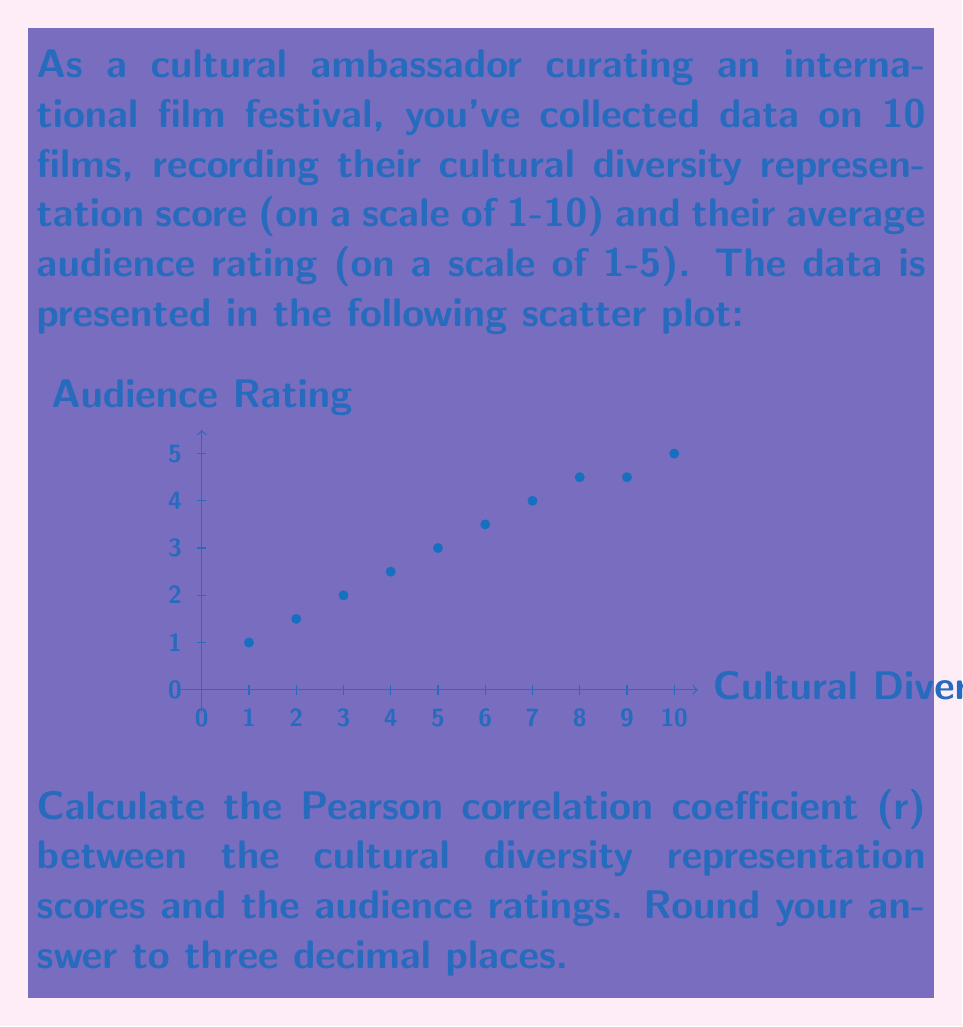Help me with this question. To calculate the Pearson correlation coefficient, we'll follow these steps:

1) First, let's organize our data:
   x (Cultural Diversity): 1, 2, 3, 4, 5, 6, 7, 8, 9, 10
   y (Audience Rating): 1, 1.5, 2, 2.5, 3, 3.5, 4, 4.5, 4.5, 5

2) Calculate the means:
   $\bar{x} = \frac{1+2+3+4+5+6+7+8+9+10}{10} = 5.5$
   $\bar{y} = \frac{1+1.5+2+2.5+3+3.5+4+4.5+4.5+5}{10} = 3.15$

3) Calculate the necessary sums:
   $\sum(x - \bar{x})(y - \bar{y})$
   $\sum(x - \bar{x})^2$
   $\sum(y - \bar{y})^2$

4) The formula for Pearson's r is:

   $$r = \frac{\sum(x - \bar{x})(y - \bar{y})}{\sqrt{\sum(x - \bar{x})^2 \sum(y - \bar{y})^2}}$$

5) Calculating the numerator:
   $\sum(x - \bar{x})(y - \bar{y}) = 28.275$

6) Calculating the denominator:
   $\sum(x - \bar{x})^2 = 82.5$
   $\sum(y - \bar{y})^2 = 13.275$
   $\sqrt{82.5 * 13.275} = 33.11$

7) Putting it all together:
   $r = \frac{28.275}{33.11} = 0.8540$

8) Rounding to three decimal places: 0.854
Answer: 0.854 